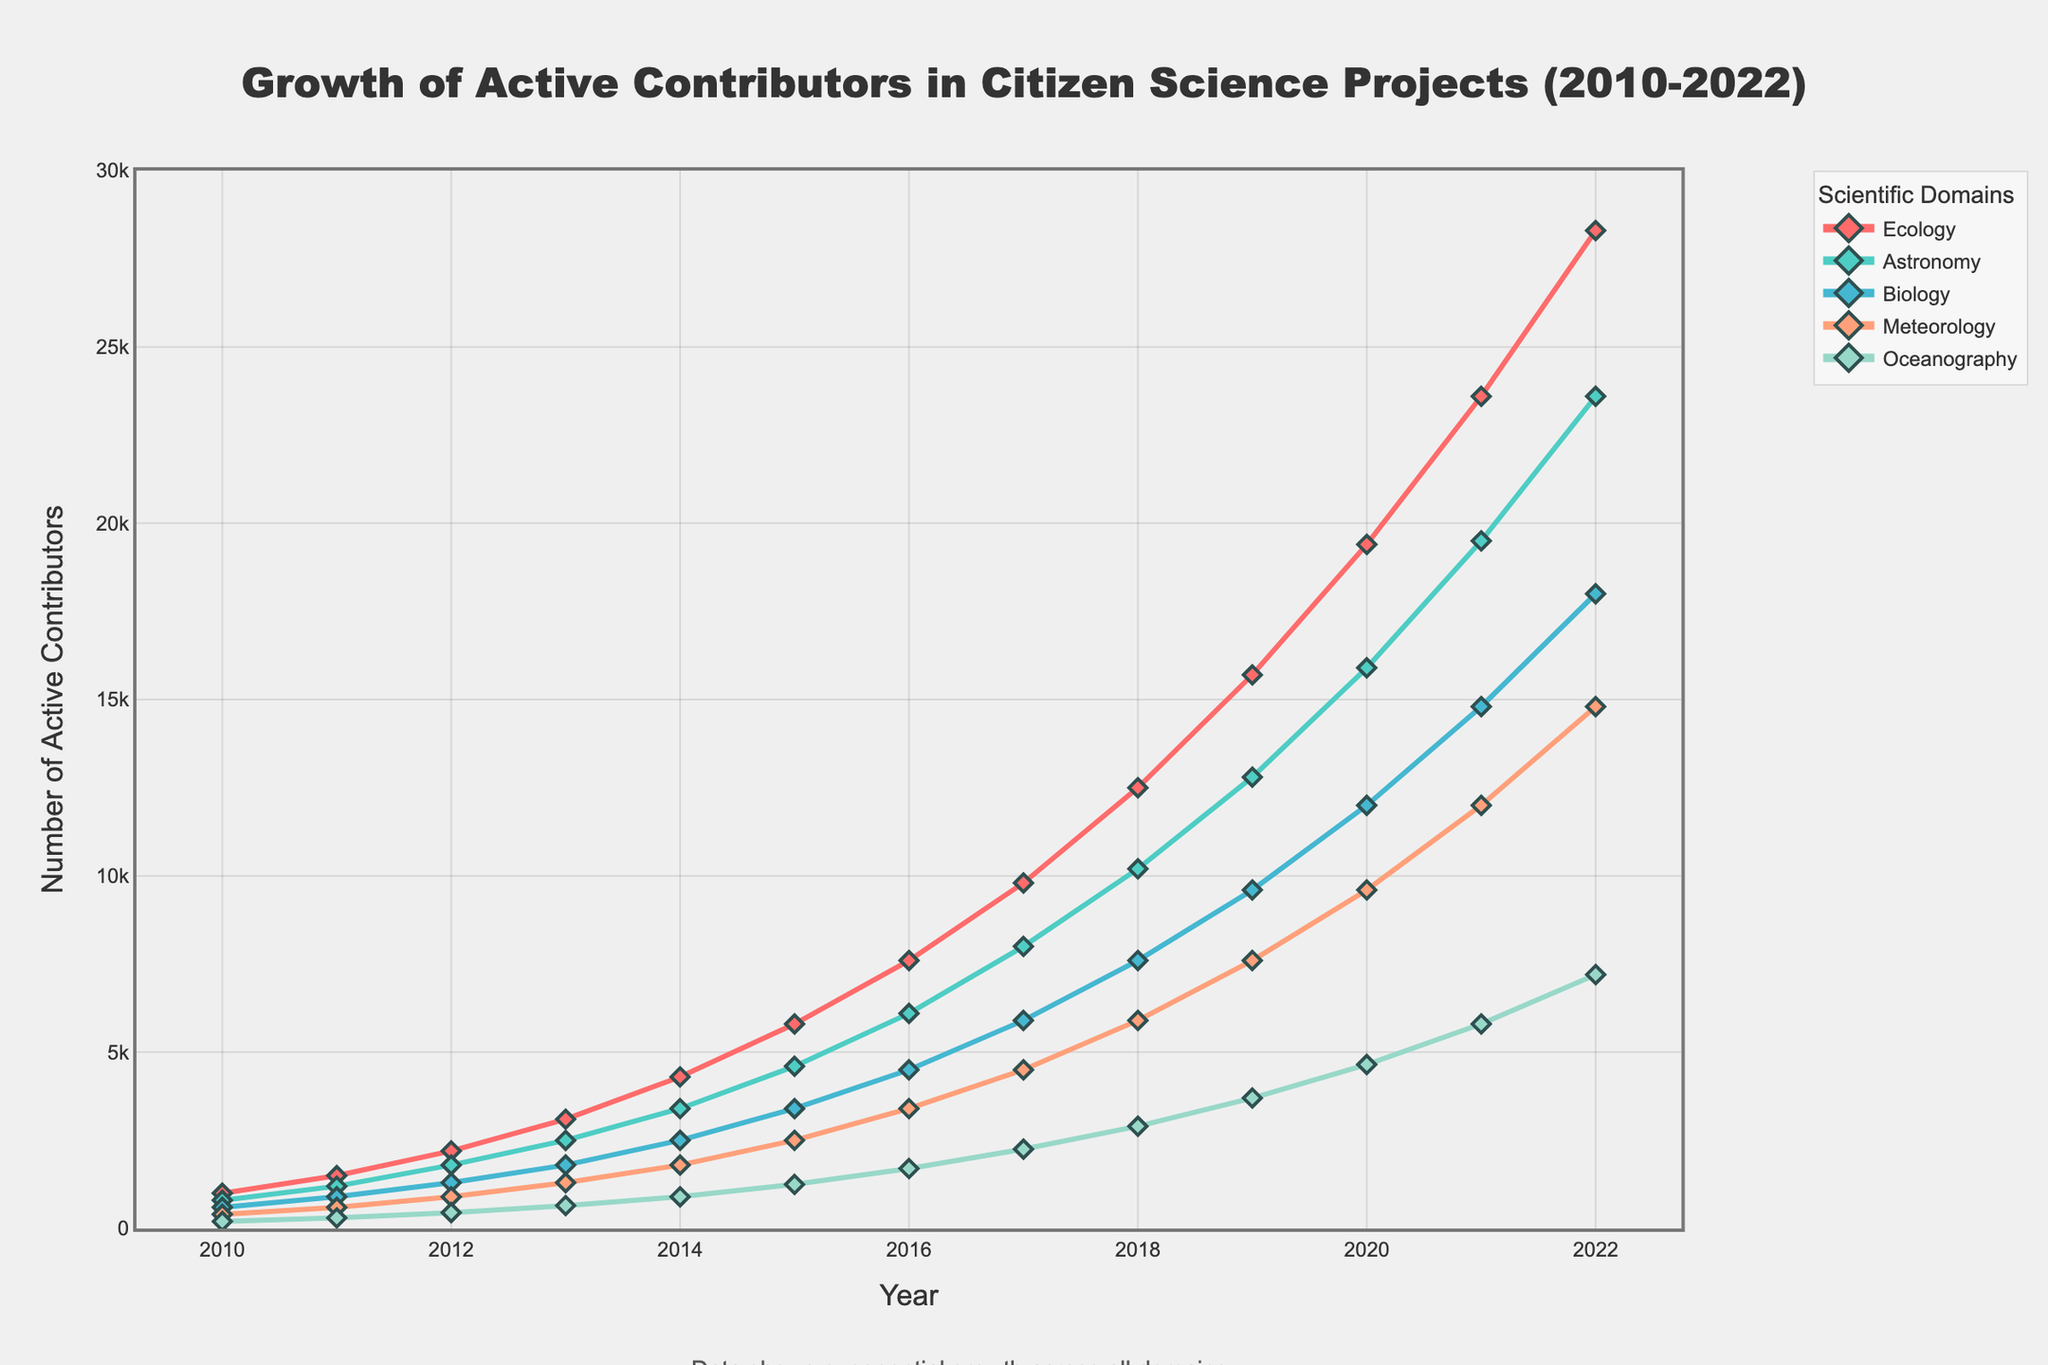What is the scientific domain with the highest number of active contributors in 2022? In 2022, the domain with the highest number of active contributors can be identified by looking at the endpoints of the lines. The pink-colored line representing Ecology ends at the highest point in 2022.
Answer: Ecology How many more active contributors were there in Biology in 2021 compared to Meteorology in 2018? From the chart, locate the point for Biology in 2021 and Meteorology in 2018. Biology in 2021 has 14,800 active contributors and Meteorology in 2018 has 5,900. The difference is 14,800 - 5,900.
Answer: 8,900 Which domain showed the least growth in active contributors between 2010 and 2022? To determine the least growth, compare the slope of each line between 2010 and 2022. Oceanography (blue line) shows the smallest increase in height over the period.
Answer: Oceanography What was the total number of active contributors across all domains in 2015? Sum the values for each domain in 2015: Ecology (5,800) + Astronomy (4,600) + Biology (3,400) + Meteorology (2,500) + Oceanography (1,250).
Answer: 17,550 In which year did Astronomy surpass Biology in the number of active contributors? Examine the intersection points of the brown line (Astronomy) and the green line (Biology). They intersect between 2016 and 2017, suggesting Astronomy surpassed Biology in 2017.
Answer: 2017 What is the average number of active contributors in Meteorology between 2013 and 2016? Sum the values for Meteorology between 2013 and 2016, then divide by the number of years: (1,300 + 1,800 + 2,500 + 3,400) / 4.
Answer: 2,250 Between 2018 and 2022, which domain had the steepest increase in active contributors? Look for the line with the steepest upward slope between 2018 and 2022. Ecology (pink line) shows the steepest increase.
Answer: Ecology How many active contributors did Ecology have in 2012 compared to Biology? Identify the values for Ecology and Biology in 2012. Ecology had 2,200 active contributors, while Biology had 1,300. To compare, calculate the difference: 2,200 - 1,300.
Answer: 900 more What year did Oceanography first exceed 5,000 active contributors? Find the point where the blue line (Oceanography) crosses the 5,000 mark, which happens in 2022.
Answer: 2022 By how much did the number of active contributors in Astronomy increase from 2010 to 2015? Locate the points for Astronomy in 2010 and 2015, then compute the difference: 4,600 - 800.
Answer: 3,800 